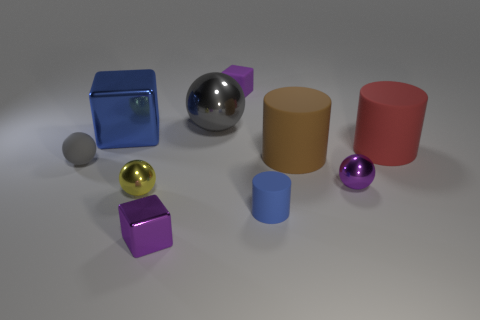Subtract all blue rubber cylinders. How many cylinders are left? 2 Subtract all yellow spheres. How many purple cubes are left? 2 Subtract all purple spheres. How many spheres are left? 3 Subtract all cylinders. How many objects are left? 7 Subtract all gray blocks. Subtract all cyan balls. How many blocks are left? 3 Add 4 tiny yellow things. How many tiny yellow things exist? 5 Subtract 0 green spheres. How many objects are left? 10 Subtract all large gray objects. Subtract all big red objects. How many objects are left? 8 Add 9 tiny purple metallic spheres. How many tiny purple metallic spheres are left? 10 